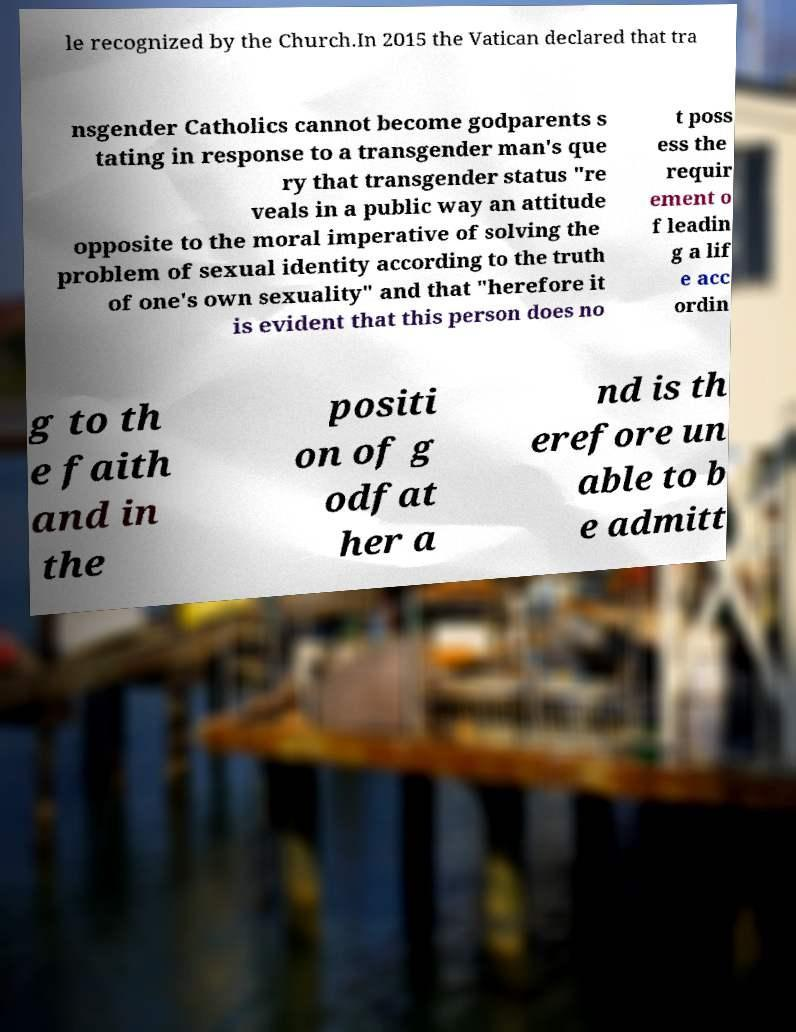Could you extract and type out the text from this image? le recognized by the Church.In 2015 the Vatican declared that tra nsgender Catholics cannot become godparents s tating in response to a transgender man's que ry that transgender status "re veals in a public way an attitude opposite to the moral imperative of solving the problem of sexual identity according to the truth of one's own sexuality" and that "herefore it is evident that this person does no t poss ess the requir ement o f leadin g a lif e acc ordin g to th e faith and in the positi on of g odfat her a nd is th erefore un able to b e admitt 